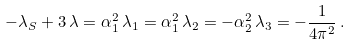Convert formula to latex. <formula><loc_0><loc_0><loc_500><loc_500>- \lambda _ { S } + 3 \, \lambda = \alpha _ { 1 } ^ { 2 } \, \lambda _ { 1 } = \alpha _ { 1 } ^ { 2 } \, \lambda _ { 2 } = - \alpha _ { 2 } ^ { 2 } \, \lambda _ { 3 } = - \frac { 1 } { 4 \pi ^ { 2 } } \, .</formula> 